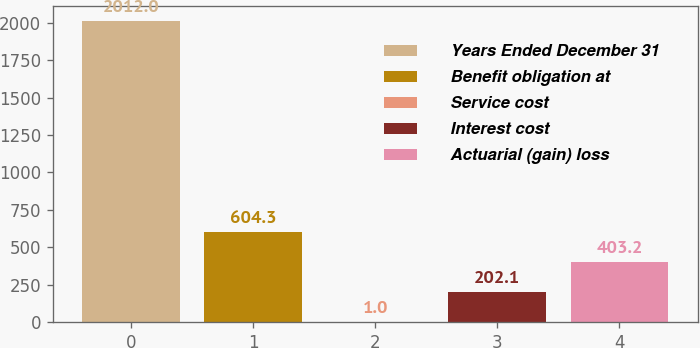Convert chart. <chart><loc_0><loc_0><loc_500><loc_500><bar_chart><fcel>Years Ended December 31<fcel>Benefit obligation at<fcel>Service cost<fcel>Interest cost<fcel>Actuarial (gain) loss<nl><fcel>2012<fcel>604.3<fcel>1<fcel>202.1<fcel>403.2<nl></chart> 